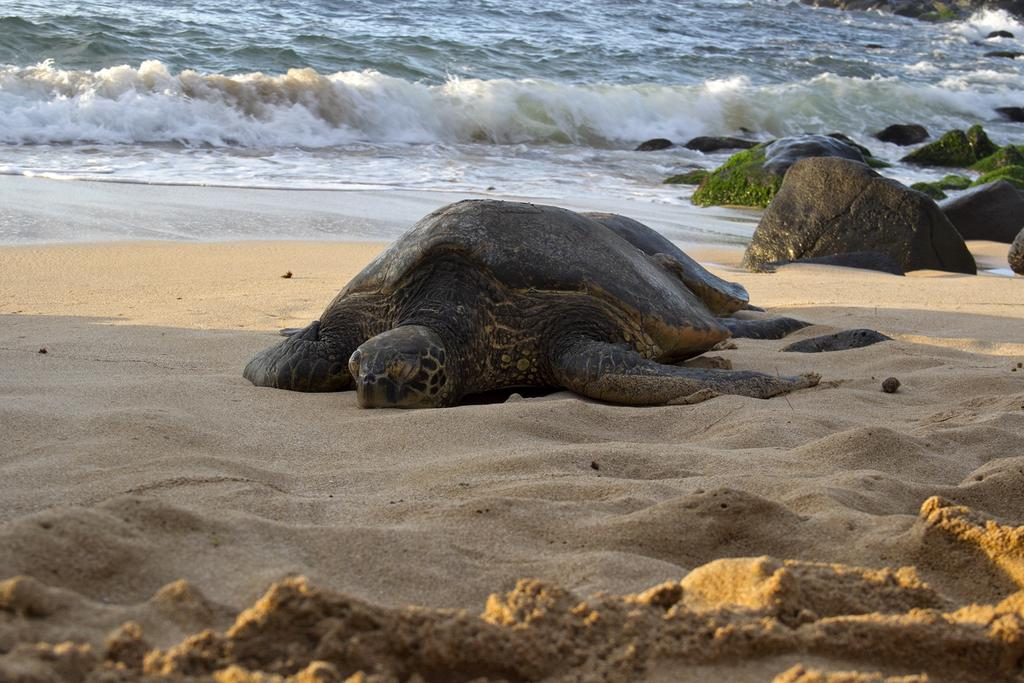What type of animals are in the image? There are tortoises in the image. What other objects or elements can be seen in the image? There are stones and sand visible in the image. What can be seen in the background of the image? There is water visible in the background of the image. How many cows are present in the image? There are no cows present in the image; it features tortoises, stones, sand, and water. What type of bun is being used as a prop in the image? There is no bun present in the image. 